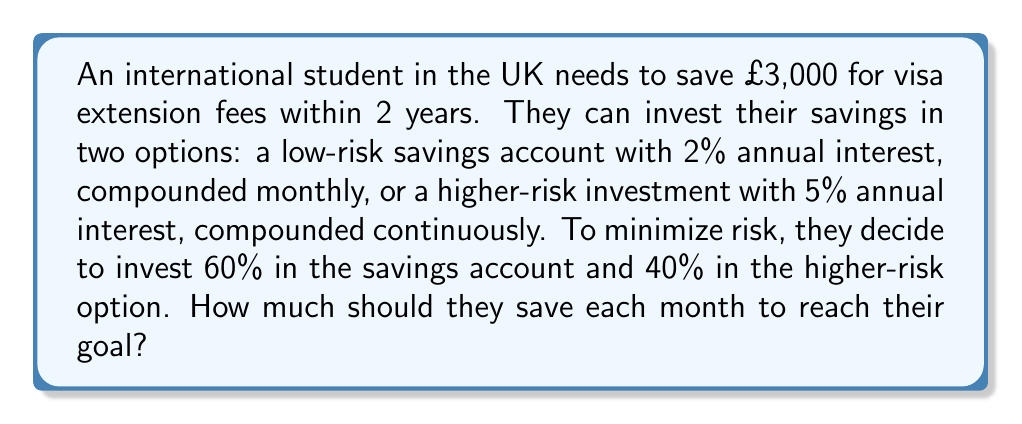Can you answer this question? Let's approach this step-by-step:

1) Let x be the monthly savings amount.

2) For the savings account (60% of savings):
   - Monthly interest rate: $r = 0.02 / 12 = 0.001667$
   - Number of months: $n = 24$
   - Future value formula: $FV = PMT \frac{(1+r)^n - 1}{r}$
   - $0.6 \cdot 3000 = 0.6x \frac{(1.001667)^{24} - 1}{0.001667}$

3) For the higher-risk investment (40% of savings):
   - Continuous compound interest formula: $A = Pe^{rt}$
   - $0.4 \cdot 3000 = 0.4x \frac{e^{0.05 \cdot 2} - 1}{0.05}$

4) Combining both equations:
   $$1800 = 0.6x \frac{(1.001667)^{24} - 1}{0.001667} + 1200 = 0.4x \frac{e^{0.1} - 1}{0.05}$$

5) Simplifying:
   $$1800 = 14.5446x + 1200 = 8.3287x$$

6) Solving for x:
   $$22.8733x = 3000$$
   $$x = 131.16$$

Therefore, the student needs to save £131.16 per month.
Answer: £131.16 per month 